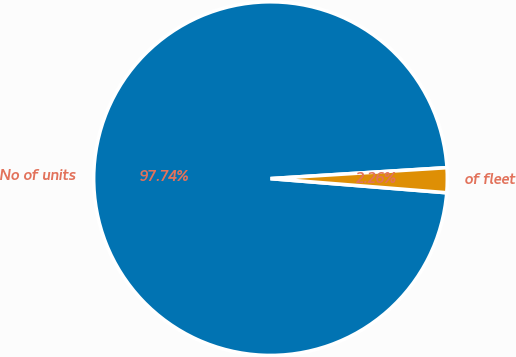Convert chart. <chart><loc_0><loc_0><loc_500><loc_500><pie_chart><fcel>No of units<fcel>of fleet<nl><fcel>97.74%<fcel>2.26%<nl></chart> 